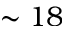Convert formula to latex. <formula><loc_0><loc_0><loc_500><loc_500>\sim 1 8</formula> 